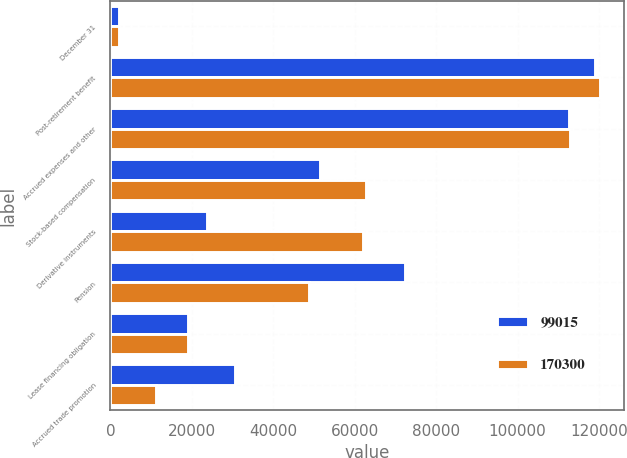<chart> <loc_0><loc_0><loc_500><loc_500><stacked_bar_chart><ecel><fcel>December 31<fcel>Post-retirement benefit<fcel>Accrued expenses and other<fcel>Stock-based compensation<fcel>Derivative instruments<fcel>Pension<fcel>Lease financing obligation<fcel>Accrued trade promotion<nl><fcel>99015<fcel>2012<fcel>119140<fcel>112760<fcel>51388<fcel>23822<fcel>72374<fcel>19035<fcel>30594<nl><fcel>170300<fcel>2011<fcel>120174<fcel>112834<fcel>62666<fcel>62117<fcel>48884<fcel>19159<fcel>11209<nl></chart> 